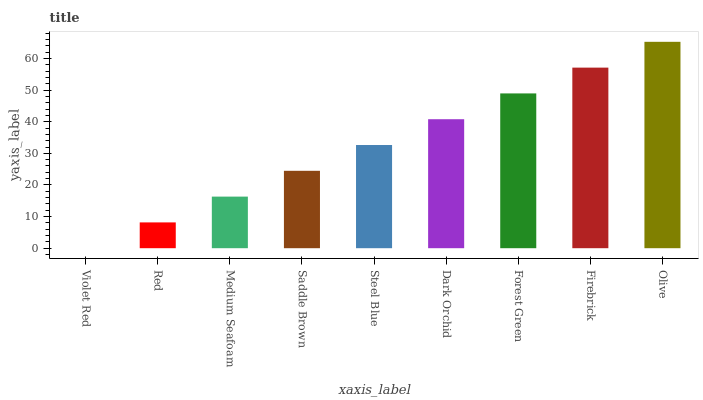Is Violet Red the minimum?
Answer yes or no. Yes. Is Olive the maximum?
Answer yes or no. Yes. Is Red the minimum?
Answer yes or no. No. Is Red the maximum?
Answer yes or no. No. Is Red greater than Violet Red?
Answer yes or no. Yes. Is Violet Red less than Red?
Answer yes or no. Yes. Is Violet Red greater than Red?
Answer yes or no. No. Is Red less than Violet Red?
Answer yes or no. No. Is Steel Blue the high median?
Answer yes or no. Yes. Is Steel Blue the low median?
Answer yes or no. Yes. Is Saddle Brown the high median?
Answer yes or no. No. Is Firebrick the low median?
Answer yes or no. No. 